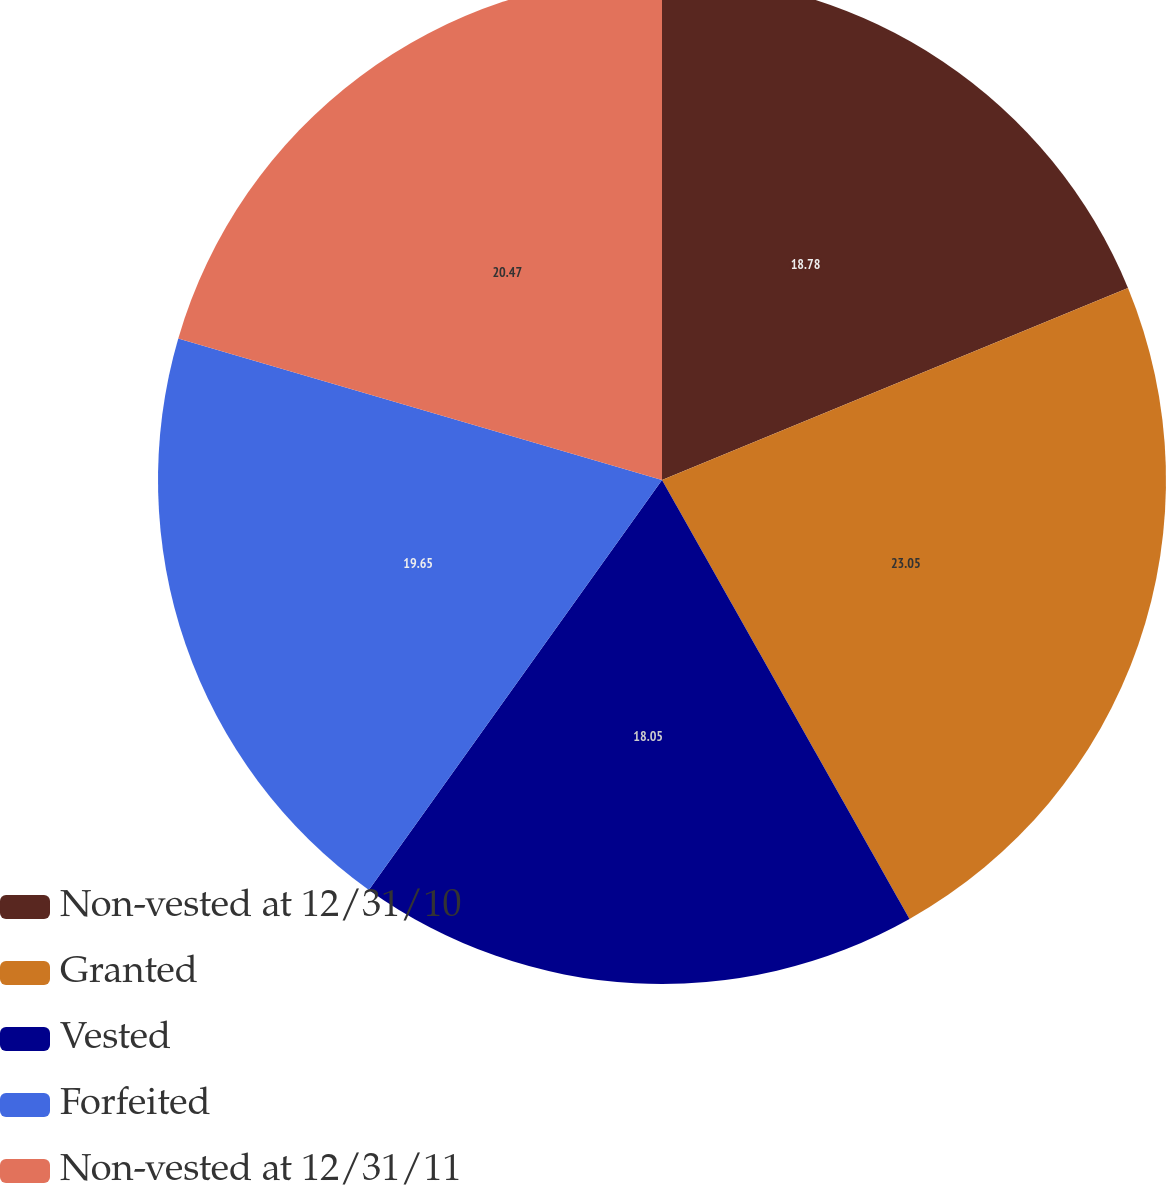Convert chart to OTSL. <chart><loc_0><loc_0><loc_500><loc_500><pie_chart><fcel>Non-vested at 12/31/10<fcel>Granted<fcel>Vested<fcel>Forfeited<fcel>Non-vested at 12/31/11<nl><fcel>18.78%<fcel>23.05%<fcel>18.05%<fcel>19.65%<fcel>20.47%<nl></chart> 